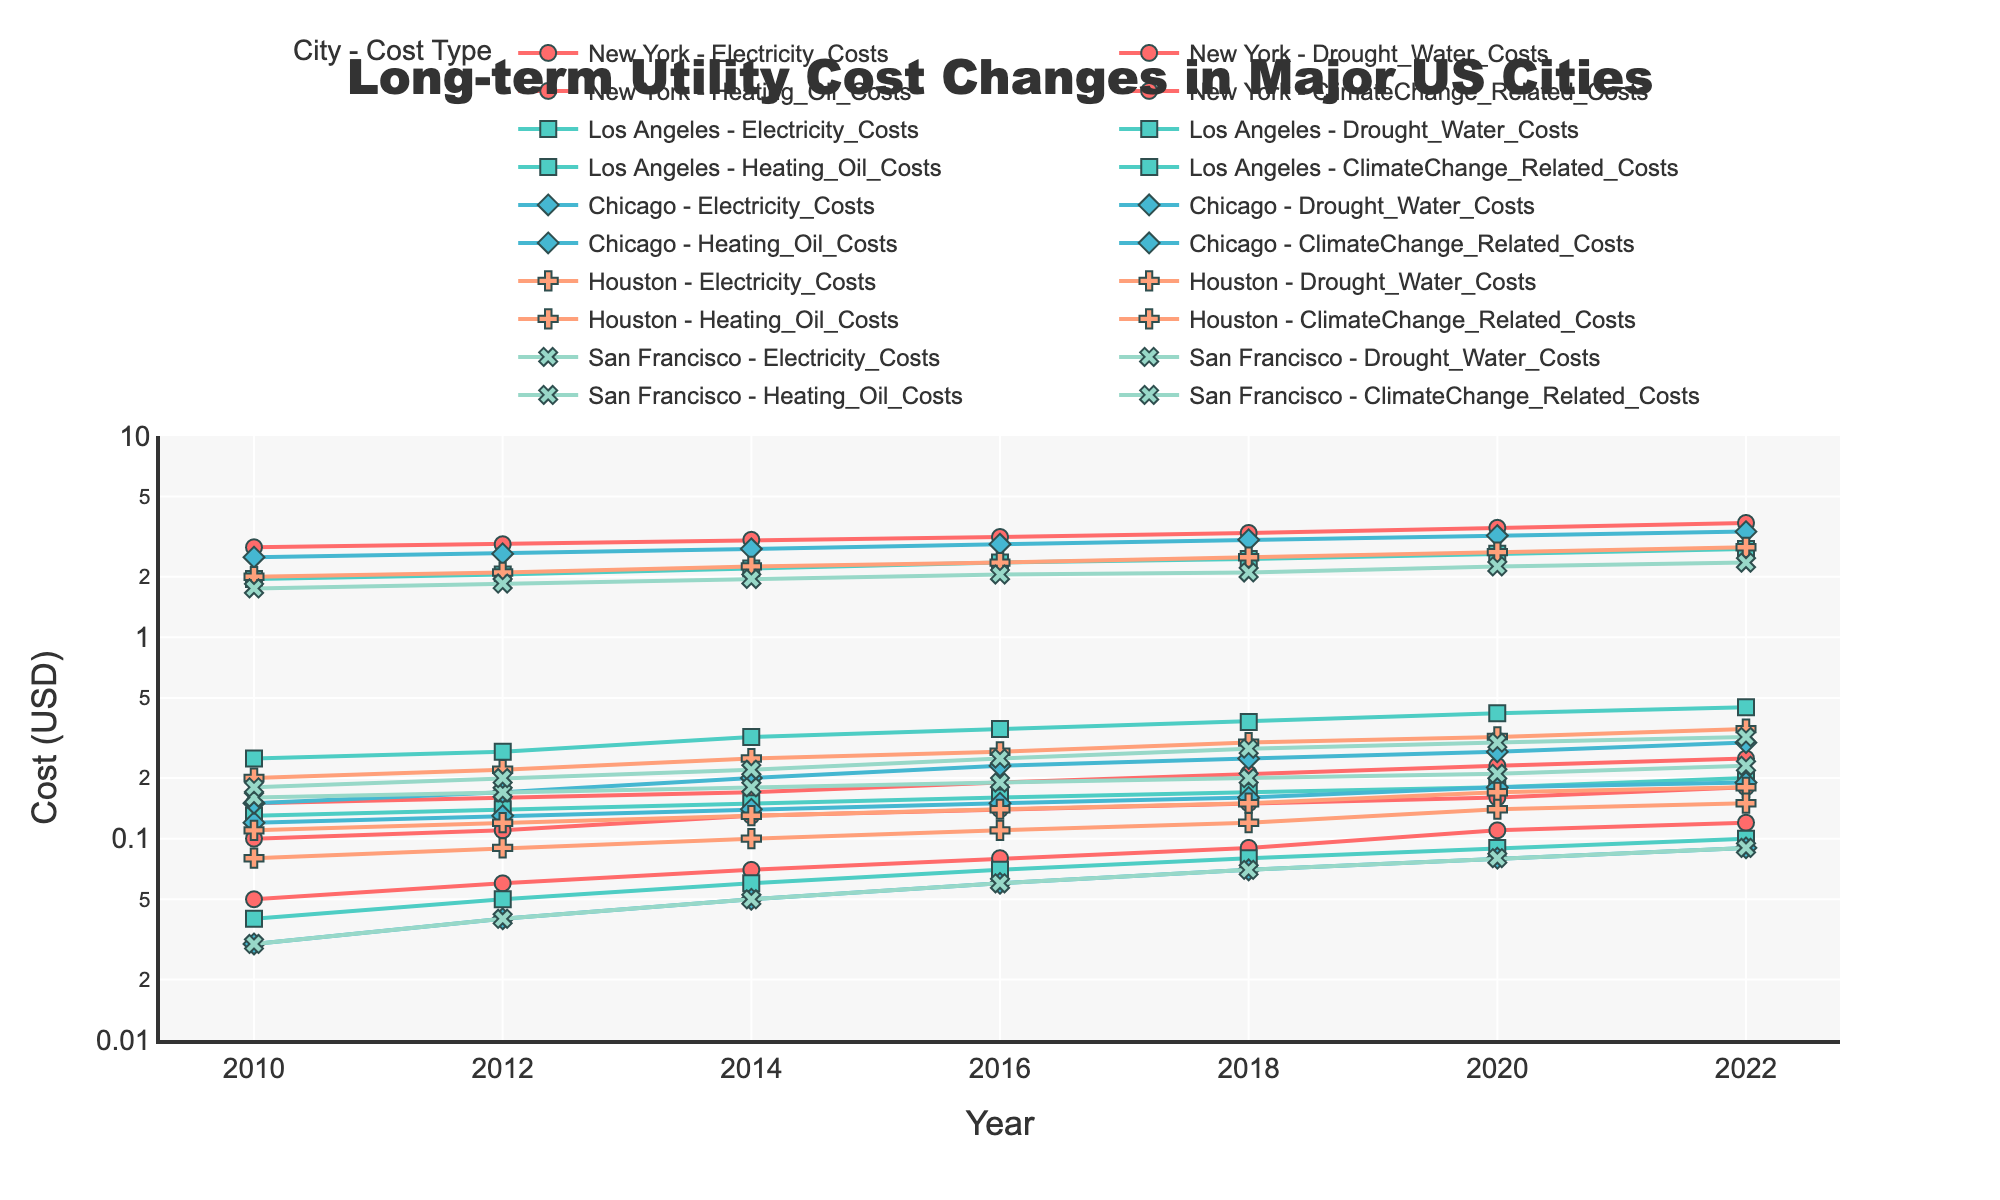What is the title of the plot? The title is displayed at the top of the figure, which clearly states the focus of the data being visualized.
Answer: Long-term Utility Cost Changes in Major US Cities Which city had the highest electricity costs in 2022? To find this, look at the data points for 2022 across different cities and compare the electricity costs. The highest point indicates the city with the highest cost.
Answer: New York How did drought water costs change over time in Los Angeles? To answer, trace the line corresponding to Los Angeles' drought water costs from 2010 to 2022. Observe whether the costs trend upwards or downwards.
Answer: Increased Which city experienced the greatest increase in heating oil costs from 2010 to 2022? Examine the heating oil costs for each city at both the start and end of the period and calculate the increase by subtracting the 2010 values from the 2022 values. The city with the largest difference had the greatest increase.
Answer: New York Did climate change-related costs always remain less than drought water costs for Chicago across the years? Compare each year's climate change-related costs to drought water costs for Chicago. If for every year, the climate change-related costs are lower than drought water costs, the statement is true.
Answer: Yes Which cost saw the highest variation in San Francisco from 2010 to 2022? To find the highest variation, subtract the lowest value from the highest value for each cost type in San Francisco. The cost type with the largest range had the highest variation.
Answer: Electricity Costs By how much did heating oil costs in Houston change between 2018 and 2022? Subtract the 2018 heating oil cost from the 2022 heating oil cost for Houston to determine the change.
Answer: 0.30 How do the 2010 electricity costs compare across New York, Los Angeles, Chicago, Houston, and San Francisco? Examine the electricity costs in 2010 for each city and list them to make a comparison.
Answer: New York: 0.15, Los Angeles: 0.13, Chicago: 0.12, Houston: 0.11, San Francisco: 0.16 What trend can be observed in climate change-related costs for all cities over the years? Look at the lines for climate change-related costs for each city to determine if they are generally increasing, decreasing, or remaining stable over time.
Answer: Increasing Which city had the smallest increase in electricity costs from 2010 to 2022? Calculate the change in electricity costs from 2010 to 2022 for each city. The city with the smallest difference has the smallest increase.
Answer: Houston 